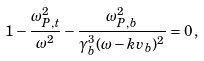Convert formula to latex. <formula><loc_0><loc_0><loc_500><loc_500>1 - \frac { \omega _ { P , t } ^ { 2 } } { \omega ^ { 2 } } - \frac { \omega _ { P , b } ^ { 2 } } { \gamma _ { b } ^ { 3 } ( \omega - k v _ { b } ) ^ { 2 } } = 0 \, ,</formula> 